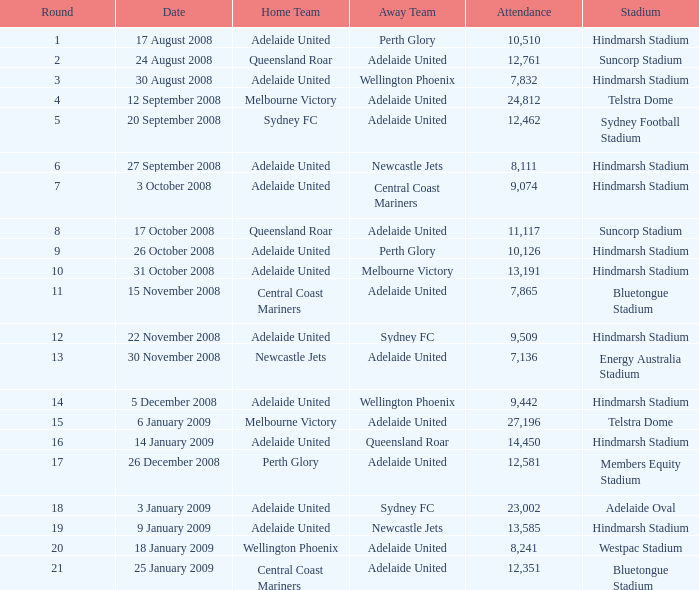What is the least round for the game played at Members Equity Stadium in from of 12,581 people? None. 